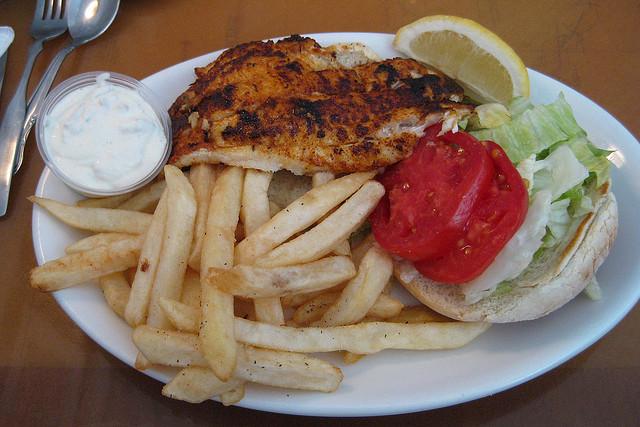What condiment is on the plate?
Short answer required. Tartar sauce. Is there a slice of lemon on the plate?
Short answer required. Yes. Are the French fries seasoned?
Concise answer only. Yes. Is the plate full?
Answer briefly. Yes. 